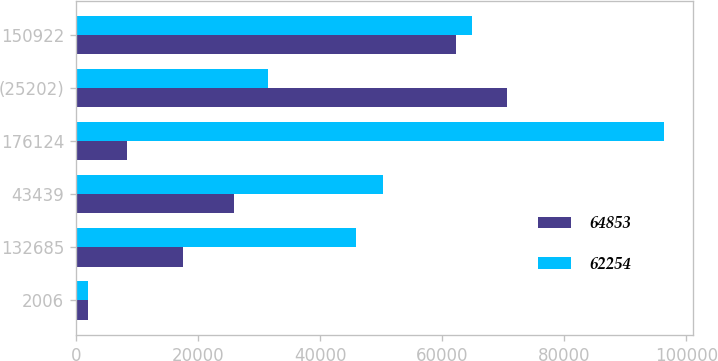Convert chart. <chart><loc_0><loc_0><loc_500><loc_500><stacked_bar_chart><ecel><fcel>2006<fcel>132685<fcel>43439<fcel>176124<fcel>(25202)<fcel>150922<nl><fcel>64853<fcel>2005<fcel>17592<fcel>25919<fcel>8327<fcel>70581<fcel>62254<nl><fcel>62254<fcel>2004<fcel>45913<fcel>50359<fcel>96272<fcel>31419<fcel>64853<nl></chart> 